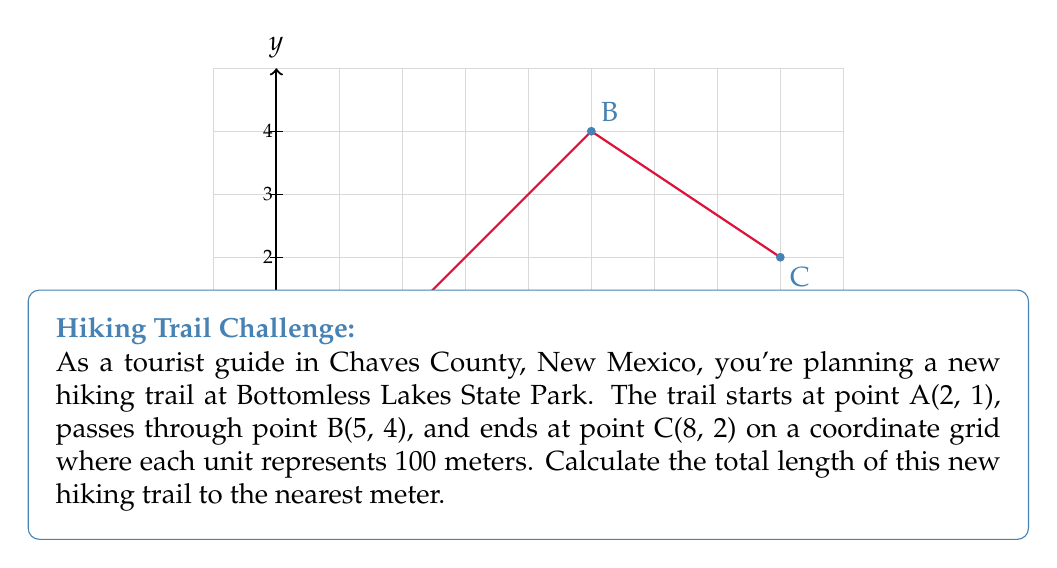Teach me how to tackle this problem. To solve this problem, we'll calculate the length of each segment of the trail (AB and BC) using the distance formula, then add them together.

1. Distance formula: $d = \sqrt{(x_2-x_1)^2 + (y_2-y_1)^2}$

2. For segment AB:
   $AB = \sqrt{(5-2)^2 + (4-1)^2}$
   $AB = \sqrt{3^2 + 3^2}$
   $AB = \sqrt{18}$
   $AB = 3\sqrt{2}$

3. For segment BC:
   $BC = \sqrt{(8-5)^2 + (2-4)^2}$
   $BC = \sqrt{3^2 + (-2)^2}$
   $BC = \sqrt{13}$

4. Total length = AB + BC
   $= 3\sqrt{2} + \sqrt{13}$

5. Convert to actual distance:
   $(3\sqrt{2} + \sqrt{13}) \times 100$ meters

6. Calculate and round to the nearest meter:
   $3\sqrt{2} \approx 4.24$
   $\sqrt{13} \approx 3.61$
   $(4.24 + 3.61) \times 100 = 785$ meters
Answer: 785 meters 